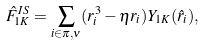Convert formula to latex. <formula><loc_0><loc_0><loc_500><loc_500>\hat { F } _ { 1 K } ^ { I S } = \sum _ { i \in \pi , \nu } ( r ^ { 3 } _ { i } - \eta r _ { i } ) Y _ { 1 K } ( \hat { r } _ { i } ) ,</formula> 